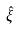Convert formula to latex. <formula><loc_0><loc_0><loc_500><loc_500>\hat { \xi }</formula> 